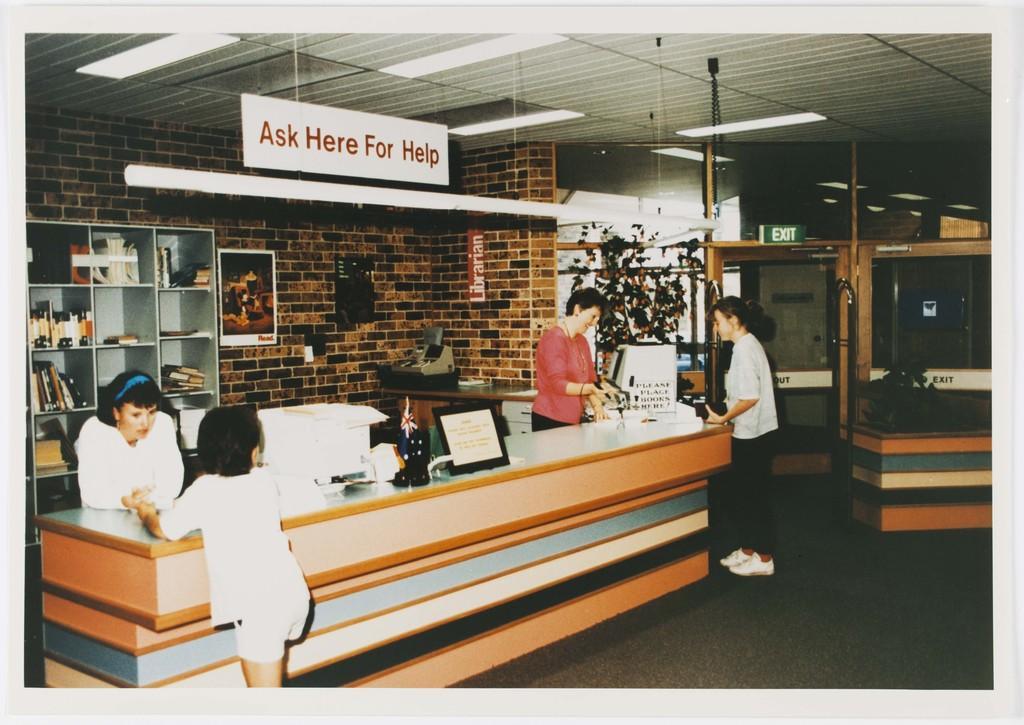Please provide a concise description of this image. In the picture we can see a desk and two women standing near it and two people are seeking help from them and on the desk, we can see any computer system and some things placed on it and in the background, we can see a wall with bricks and some photo frame to it and some racks with a book and besides we can see an exit door and to the ceiling we can see a board ask here for help and we can see some lights. 